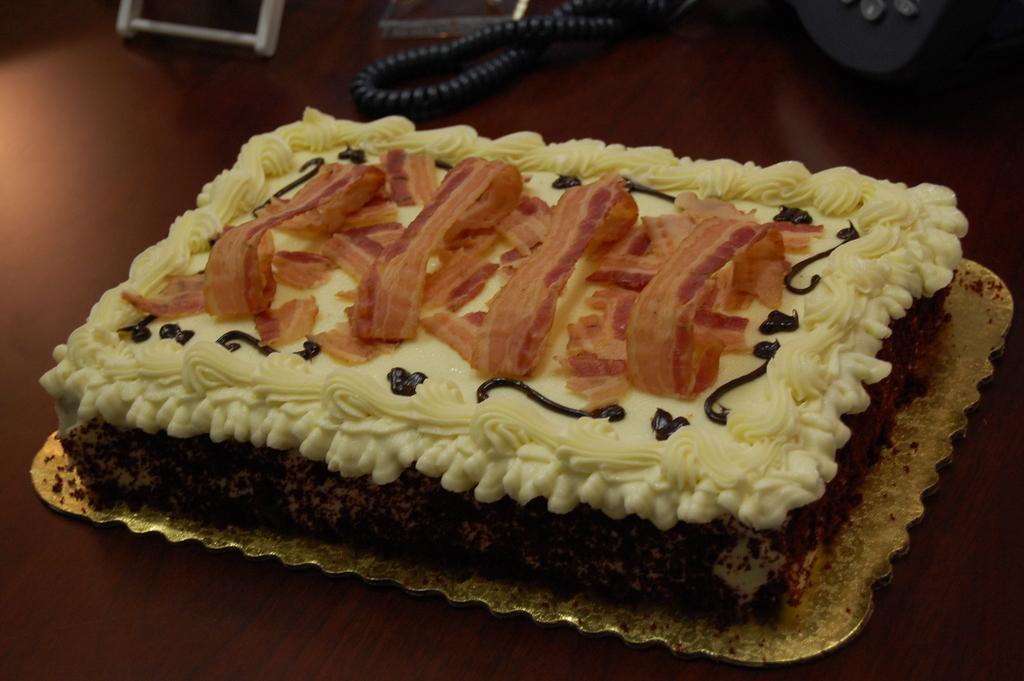Describe this image in one or two sentences. In this picture we can see a cake on a platform and in the background we can see a spring. 